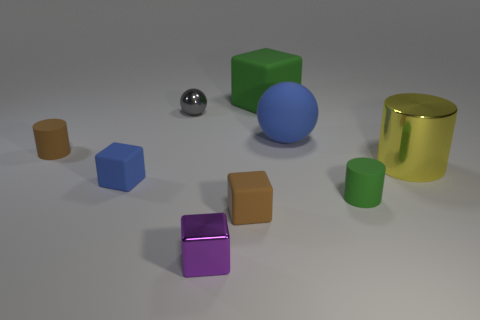Is there a tiny brown matte block that is in front of the tiny brown rubber object that is in front of the small brown thing left of the brown rubber block?
Offer a terse response. No. How many small things are yellow metallic cylinders or matte objects?
Make the answer very short. 4. What is the color of the metallic cube that is the same size as the gray ball?
Make the answer very short. Purple. There is a yellow cylinder; how many green things are on the left side of it?
Ensure brevity in your answer.  2. Are there any small gray balls that have the same material as the blue sphere?
Your answer should be compact. No. There is a rubber thing that is the same color as the matte ball; what shape is it?
Provide a succinct answer. Cube. There is a small shiny object in front of the tiny gray ball; what is its color?
Your answer should be compact. Purple. Are there an equal number of gray balls that are behind the green block and large blocks that are in front of the matte sphere?
Offer a terse response. Yes. There is a small cylinder left of the green thing to the left of the matte ball; what is it made of?
Give a very brief answer. Rubber. How many things are either blue rubber cubes or matte objects that are in front of the large green rubber block?
Make the answer very short. 5. 